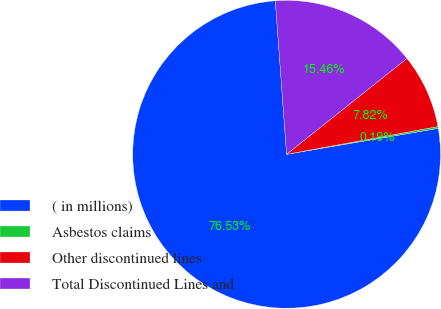Convert chart to OTSL. <chart><loc_0><loc_0><loc_500><loc_500><pie_chart><fcel>( in millions)<fcel>Asbestos claims<fcel>Other discontinued lines<fcel>Total Discontinued Lines and<nl><fcel>76.53%<fcel>0.19%<fcel>7.82%<fcel>15.46%<nl></chart> 